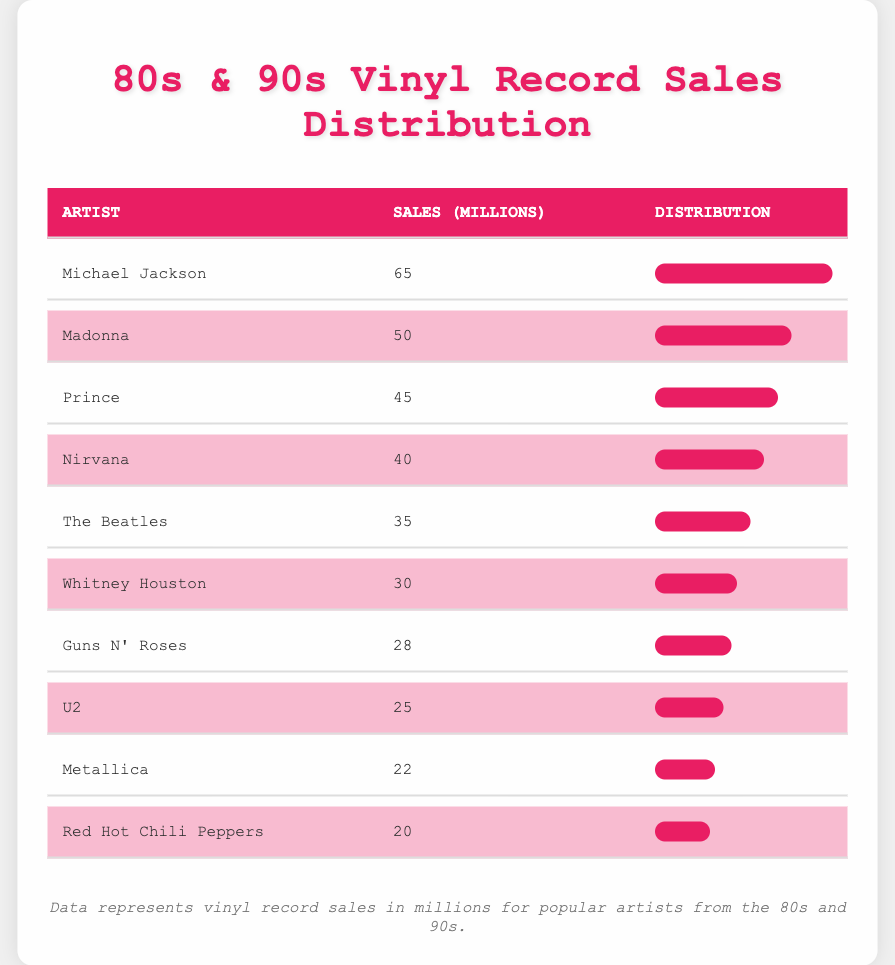What artist has the highest vinyl record sales? By looking at the sales figures in the table, we find that Michael Jackson has the highest sales at 65 million.
Answer: Michael Jackson What are the vinyl sales of Madonna? The table shows that Madonna's vinyl record sales are 50 million.
Answer: 50 million What is the total vinyl record sales for the top three artists? We need to sum the sales of the top three artists: Michael Jackson (65 million), Madonna (50 million), and Prince (45 million). Adding these gives us 65 + 50 + 45 = 160 million.
Answer: 160 million Did Guns N' Roses sell more vinyl records than U2? By comparing their sales figures in the table, we see that Guns N' Roses sold 28 million and U2 sold 25 million. Since 28 million is greater than 25 million, the answer is yes.
Answer: Yes What is the average vinyl record sales of the artists listed? To find the average, we sum all the sales: 65 + 50 + 45 + 40 + 35 + 30 + 28 + 25 + 22 + 20 = 390 million. There are 10 artists, so the average is 390 / 10 = 39 million.
Answer: 39 million Is it true that Red Hot Chili Peppers sold at least 30 million records? The sales figure for Red Hot Chili Peppers in the table shows 20 million. Since 20 million is less than 30 million, the statement is false.
Answer: No Which artist has vinyl sales closest to the average? The average is 39 million. We compare each artist's sales to determine which is closest. The sales figures for Whitney Houston (30 million) is 9 million below, and Nirvana (40 million) is 1 million above. Thus, Nirvana has sales closest to the average.
Answer: Nirvana What is the sales difference between the highest and lowest selling artists? The highest-selling artist is Michael Jackson with 65 million, and the lowest is Red Hot Chili Peppers with 20 million. The difference is 65 - 20 = 45 million.
Answer: 45 million How many artists sold more than 30 million vinyl records? By looking at the table, we see that Michael Jackson, Madonna, Prince, Nirvana, The Beatles, and Whitney Houston have sales above 30 million. Counting them gives us 6 artists.
Answer: 6 artists 